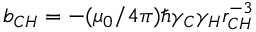Convert formula to latex. <formula><loc_0><loc_0><loc_500><loc_500>b _ { C H } = - ( \mu _ { 0 } / 4 \pi ) \hbar { \gamma } _ { C } \gamma _ { H } r _ { C H } ^ { - 3 }</formula> 